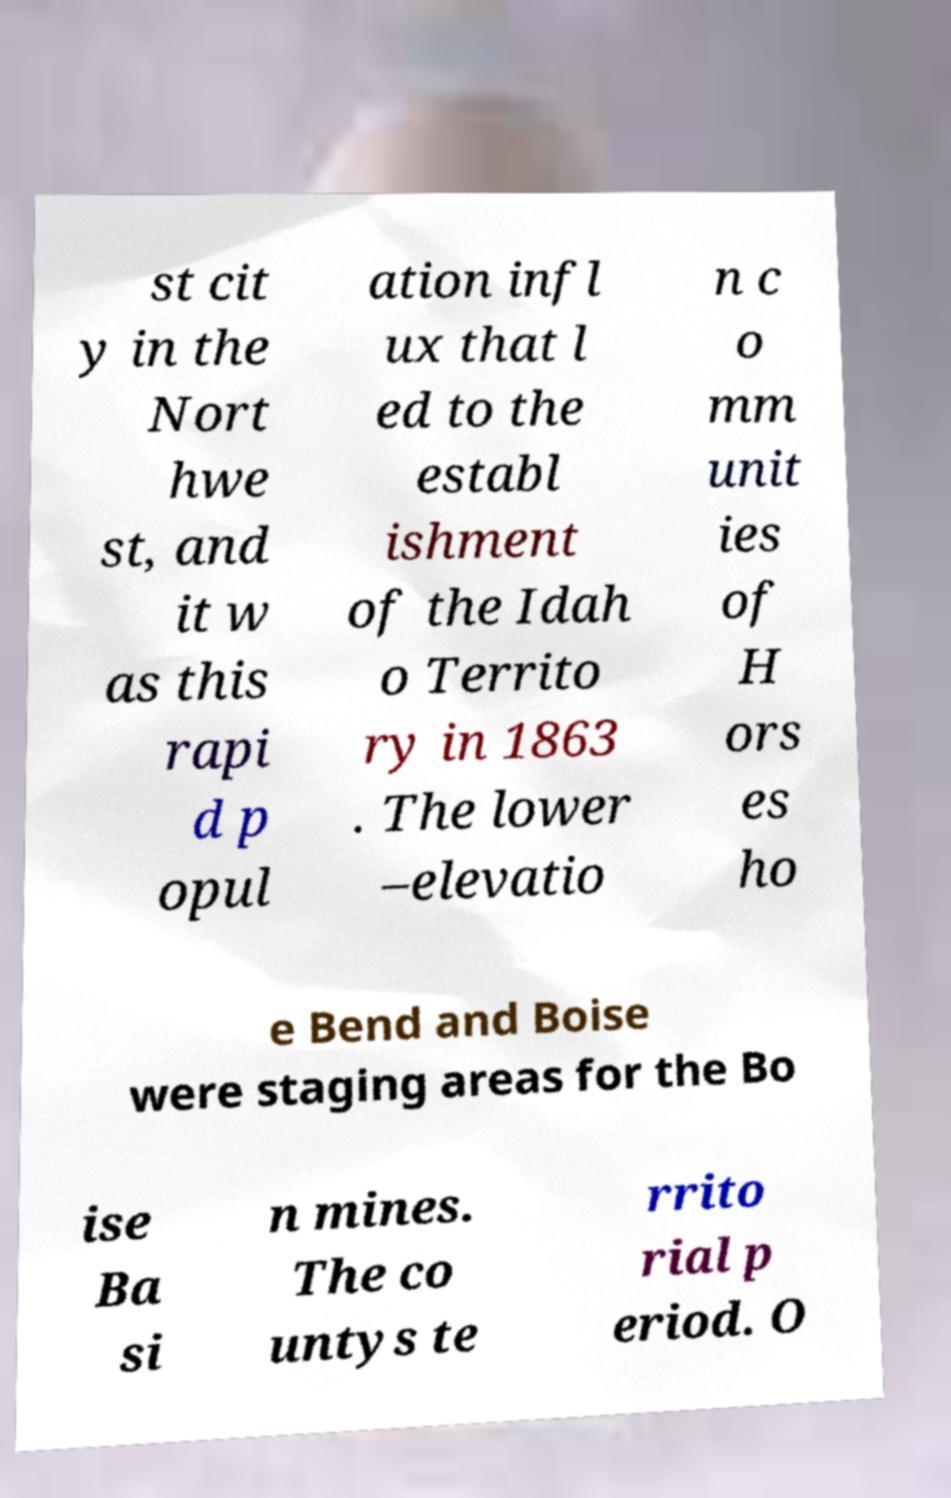Please identify and transcribe the text found in this image. st cit y in the Nort hwe st, and it w as this rapi d p opul ation infl ux that l ed to the establ ishment of the Idah o Territo ry in 1863 . The lower –elevatio n c o mm unit ies of H ors es ho e Bend and Boise were staging areas for the Bo ise Ba si n mines. The co untys te rrito rial p eriod. O 